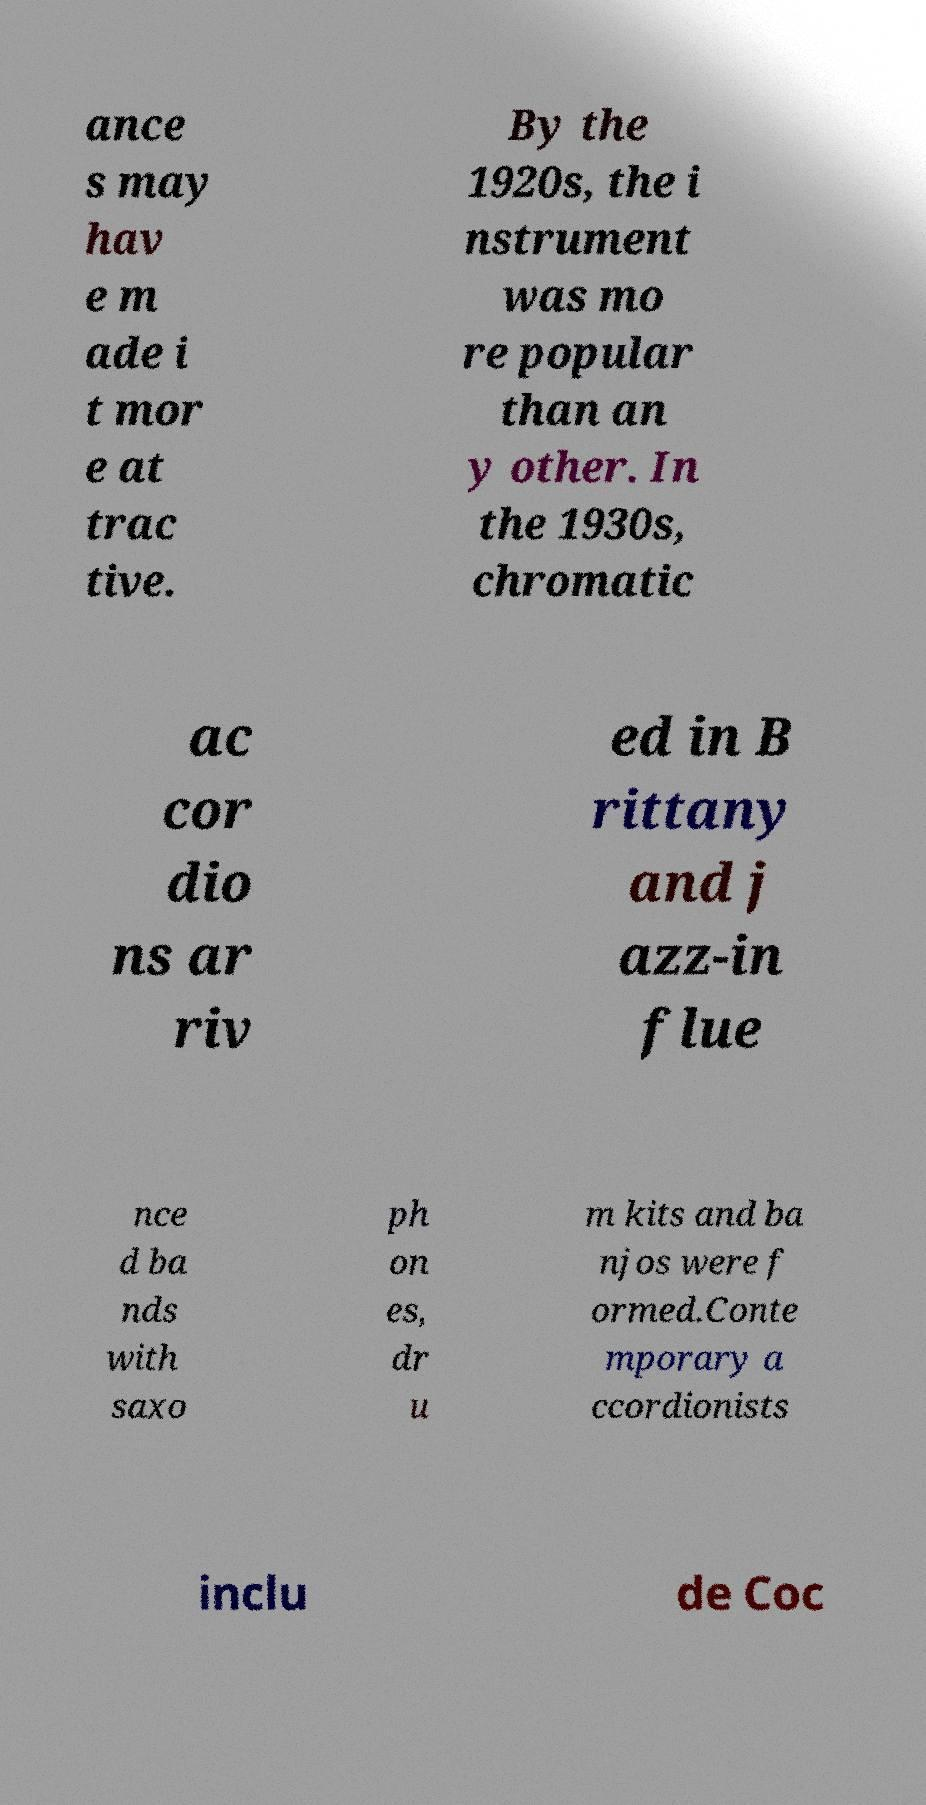Can you read and provide the text displayed in the image?This photo seems to have some interesting text. Can you extract and type it out for me? ance s may hav e m ade i t mor e at trac tive. By the 1920s, the i nstrument was mo re popular than an y other. In the 1930s, chromatic ac cor dio ns ar riv ed in B rittany and j azz-in flue nce d ba nds with saxo ph on es, dr u m kits and ba njos were f ormed.Conte mporary a ccordionists inclu de Coc 